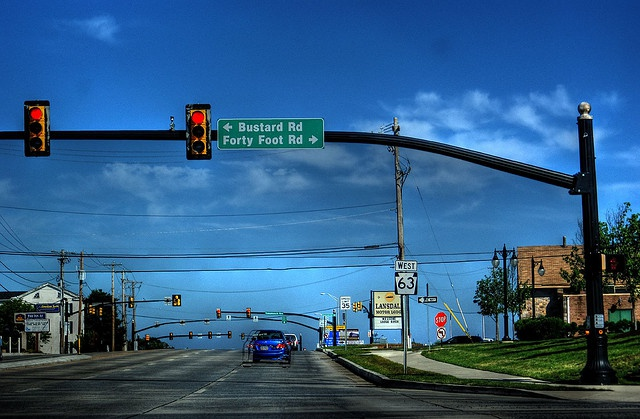Describe the objects in this image and their specific colors. I can see traffic light in blue, black, red, maroon, and gray tones, car in blue, black, navy, and darkblue tones, traffic light in blue, black, olive, red, and maroon tones, traffic light in blue, black, lightblue, and teal tones, and stop sign in blue, red, brown, and darkgray tones in this image. 